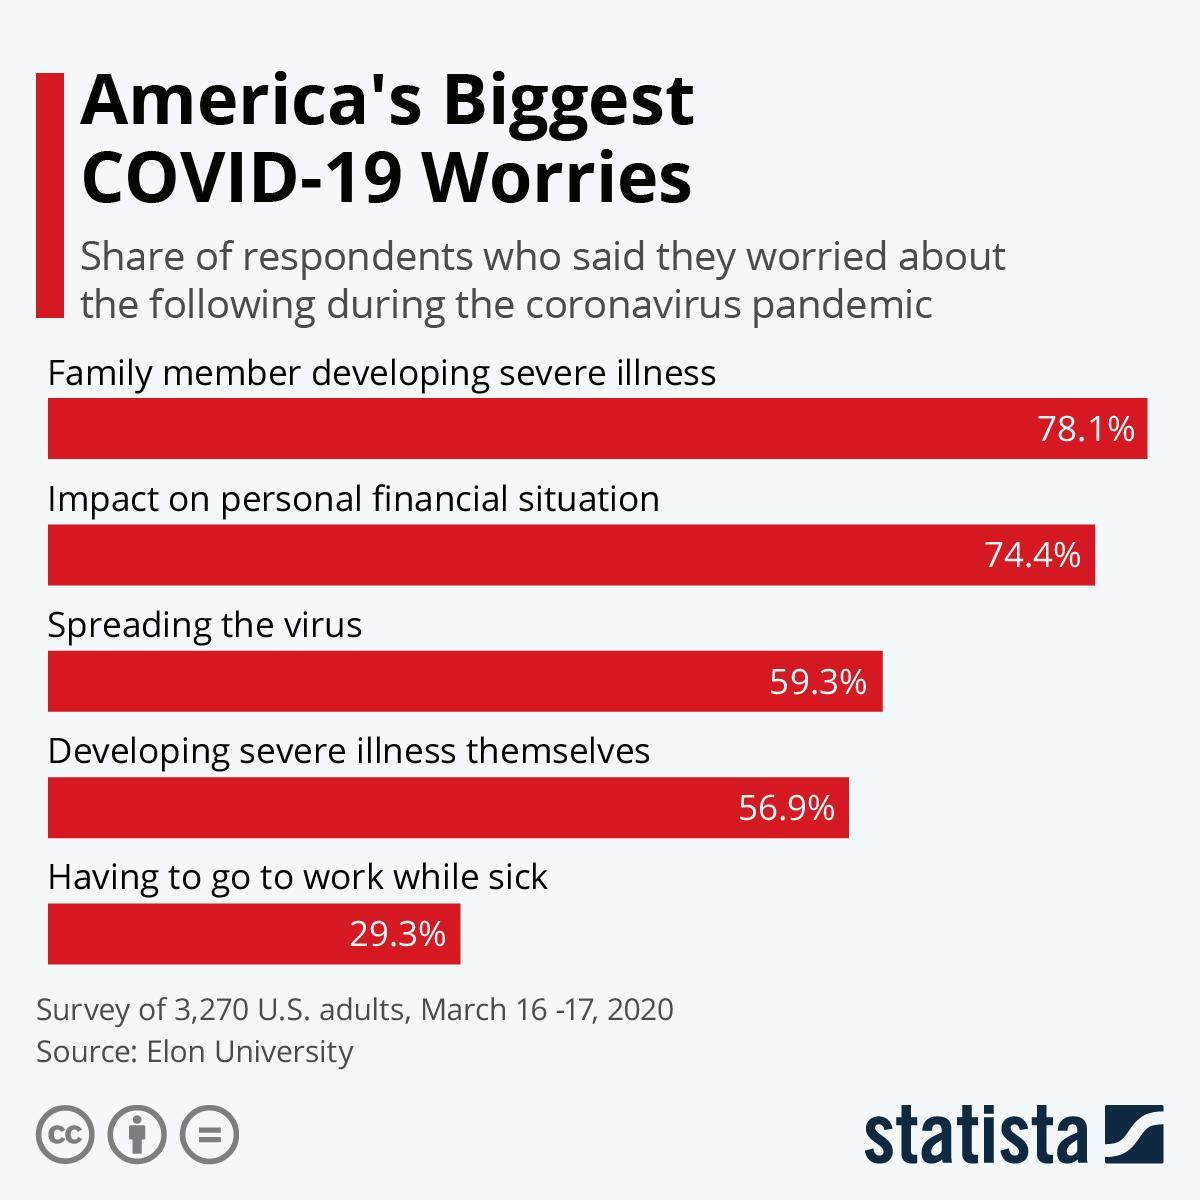What was the least worried matter?
Answer the question with a short phrase. Having to go to work while sick What percent of people are worried about spreading the disease? 59.3% 